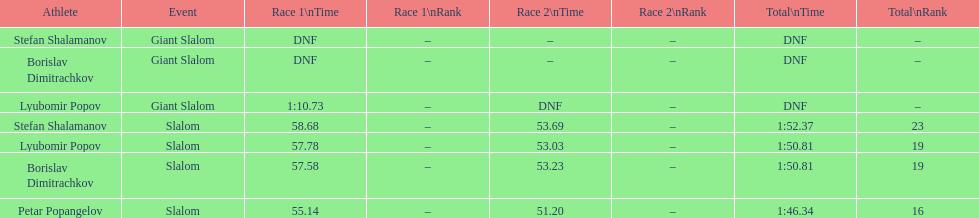What is the rank number of stefan shalamanov in the slalom event 23. 